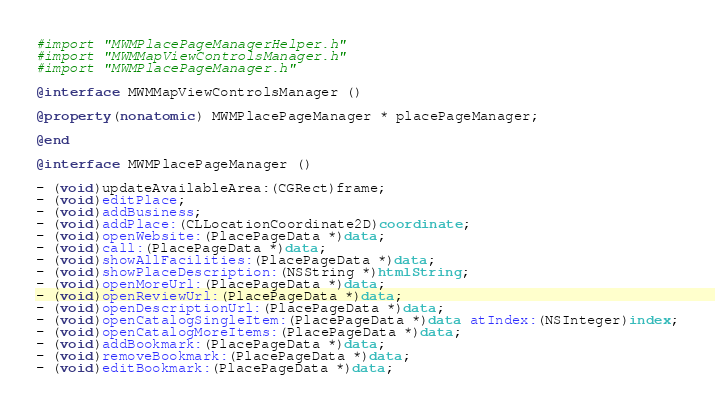<code> <loc_0><loc_0><loc_500><loc_500><_ObjectiveC_>#import "MWMPlacePageManagerHelper.h"
#import "MWMMapViewControlsManager.h"
#import "MWMPlacePageManager.h"

@interface MWMMapViewControlsManager ()

@property(nonatomic) MWMPlacePageManager * placePageManager;

@end

@interface MWMPlacePageManager ()

- (void)updateAvailableArea:(CGRect)frame;
- (void)editPlace;
- (void)addBusiness;
- (void)addPlace:(CLLocationCoordinate2D)coordinate;
- (void)openWebsite:(PlacePageData *)data;
- (void)call:(PlacePageData *)data;
- (void)showAllFacilities:(PlacePageData *)data;
- (void)showPlaceDescription:(NSString *)htmlString;
- (void)openMoreUrl:(PlacePageData *)data;
- (void)openReviewUrl:(PlacePageData *)data;
- (void)openDescriptionUrl:(PlacePageData *)data;
- (void)openCatalogSingleItem:(PlacePageData *)data atIndex:(NSInteger)index;
- (void)openCatalogMoreItems:(PlacePageData *)data;
- (void)addBookmark:(PlacePageData *)data;
- (void)removeBookmark:(PlacePageData *)data;
- (void)editBookmark:(PlacePageData *)data;</code> 